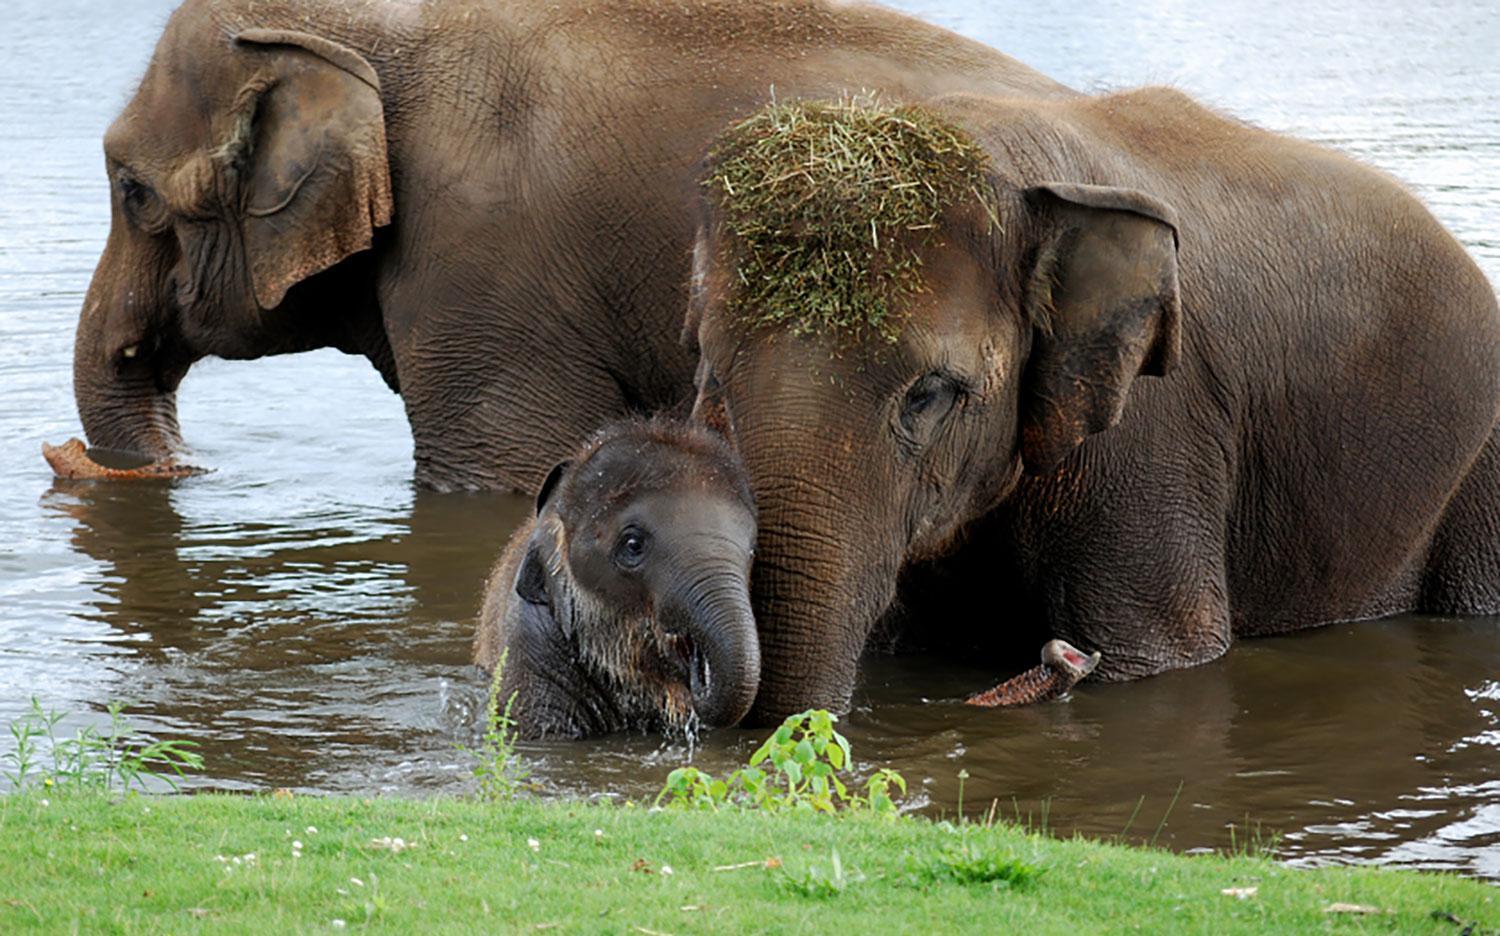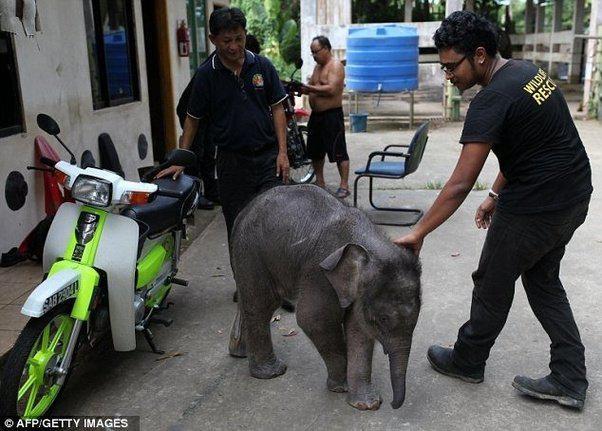The first image is the image on the left, the second image is the image on the right. Examine the images to the left and right. Is the description "The elephants in the image on the right are butting heads." accurate? Answer yes or no. No. The first image is the image on the left, the second image is the image on the right. Analyze the images presented: Is the assertion "An image shows two adult elephants next to a baby elephant." valid? Answer yes or no. Yes. 